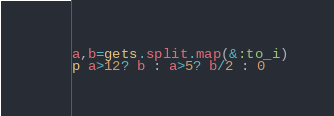<code> <loc_0><loc_0><loc_500><loc_500><_Ruby_>a,b=gets.split.map(&:to_i)
p a>12? b : a>5? b/2 : 0</code> 